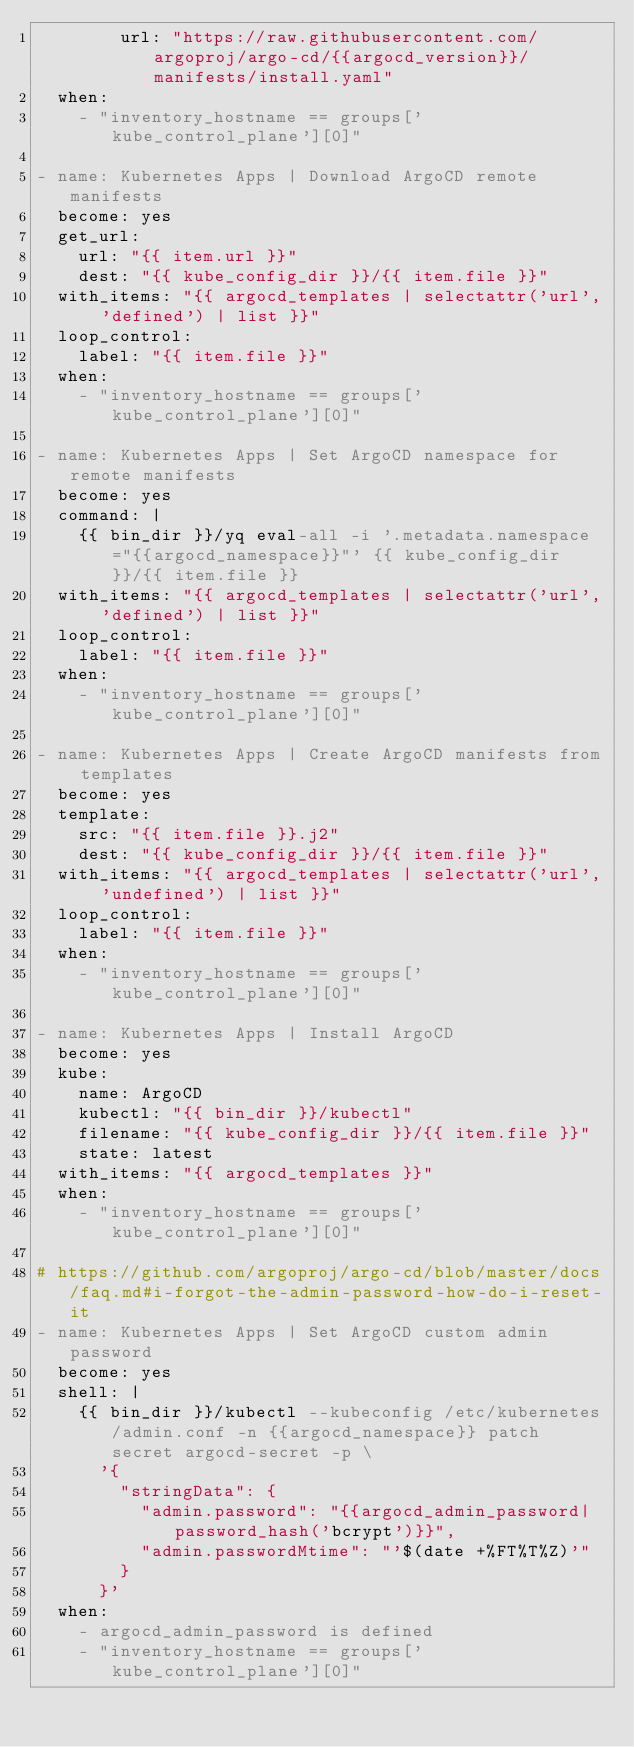Convert code to text. <code><loc_0><loc_0><loc_500><loc_500><_YAML_>        url: "https://raw.githubusercontent.com/argoproj/argo-cd/{{argocd_version}}/manifests/install.yaml"
  when:
    - "inventory_hostname == groups['kube_control_plane'][0]"

- name: Kubernetes Apps | Download ArgoCD remote manifests
  become: yes
  get_url:
    url: "{{ item.url }}"
    dest: "{{ kube_config_dir }}/{{ item.file }}"
  with_items: "{{ argocd_templates | selectattr('url', 'defined') | list }}"
  loop_control:
    label: "{{ item.file }}"
  when:
    - "inventory_hostname == groups['kube_control_plane'][0]"

- name: Kubernetes Apps | Set ArgoCD namespace for remote manifests
  become: yes
  command: |
    {{ bin_dir }}/yq eval-all -i '.metadata.namespace="{{argocd_namespace}}"' {{ kube_config_dir }}/{{ item.file }}
  with_items: "{{ argocd_templates | selectattr('url', 'defined') | list }}"
  loop_control:
    label: "{{ item.file }}"
  when:
    - "inventory_hostname == groups['kube_control_plane'][0]"

- name: Kubernetes Apps | Create ArgoCD manifests from templates
  become: yes
  template:
    src: "{{ item.file }}.j2"
    dest: "{{ kube_config_dir }}/{{ item.file }}"
  with_items: "{{ argocd_templates | selectattr('url', 'undefined') | list }}"
  loop_control:
    label: "{{ item.file }}"
  when:
    - "inventory_hostname == groups['kube_control_plane'][0]"

- name: Kubernetes Apps | Install ArgoCD
  become: yes
  kube:
    name: ArgoCD
    kubectl: "{{ bin_dir }}/kubectl"
    filename: "{{ kube_config_dir }}/{{ item.file }}"
    state: latest
  with_items: "{{ argocd_templates }}"
  when:
    - "inventory_hostname == groups['kube_control_plane'][0]"

# https://github.com/argoproj/argo-cd/blob/master/docs/faq.md#i-forgot-the-admin-password-how-do-i-reset-it
- name: Kubernetes Apps | Set ArgoCD custom admin password
  become: yes
  shell: |
    {{ bin_dir }}/kubectl --kubeconfig /etc/kubernetes/admin.conf -n {{argocd_namespace}} patch secret argocd-secret -p \
      '{
        "stringData": {
          "admin.password": "{{argocd_admin_password|password_hash('bcrypt')}}",
          "admin.passwordMtime": "'$(date +%FT%T%Z)'"
        }
      }'
  when:
    - argocd_admin_password is defined
    - "inventory_hostname == groups['kube_control_plane'][0]"
</code> 